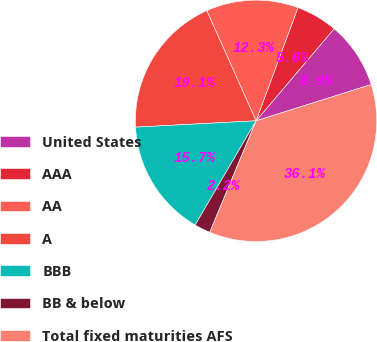Convert chart. <chart><loc_0><loc_0><loc_500><loc_500><pie_chart><fcel>United States<fcel>AAA<fcel>AA<fcel>A<fcel>BBB<fcel>BB & below<fcel>Total fixed maturities AFS<nl><fcel>8.95%<fcel>5.55%<fcel>12.34%<fcel>19.14%<fcel>15.74%<fcel>2.15%<fcel>36.13%<nl></chart> 